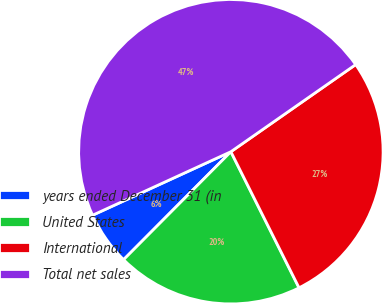<chart> <loc_0><loc_0><loc_500><loc_500><pie_chart><fcel>years ended December 31 (in<fcel>United States<fcel>International<fcel>Total net sales<nl><fcel>5.7%<fcel>19.84%<fcel>27.31%<fcel>47.15%<nl></chart> 